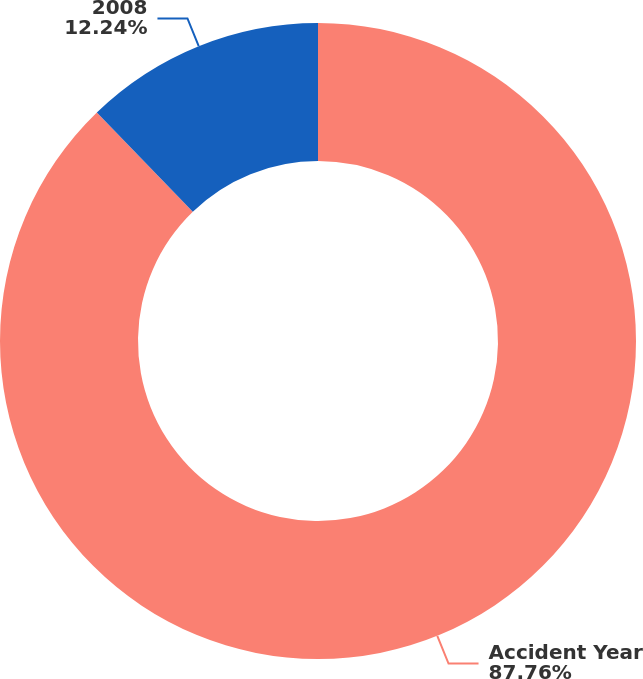Convert chart to OTSL. <chart><loc_0><loc_0><loc_500><loc_500><pie_chart><fcel>Accident Year<fcel>2008<nl><fcel>87.76%<fcel>12.24%<nl></chart> 